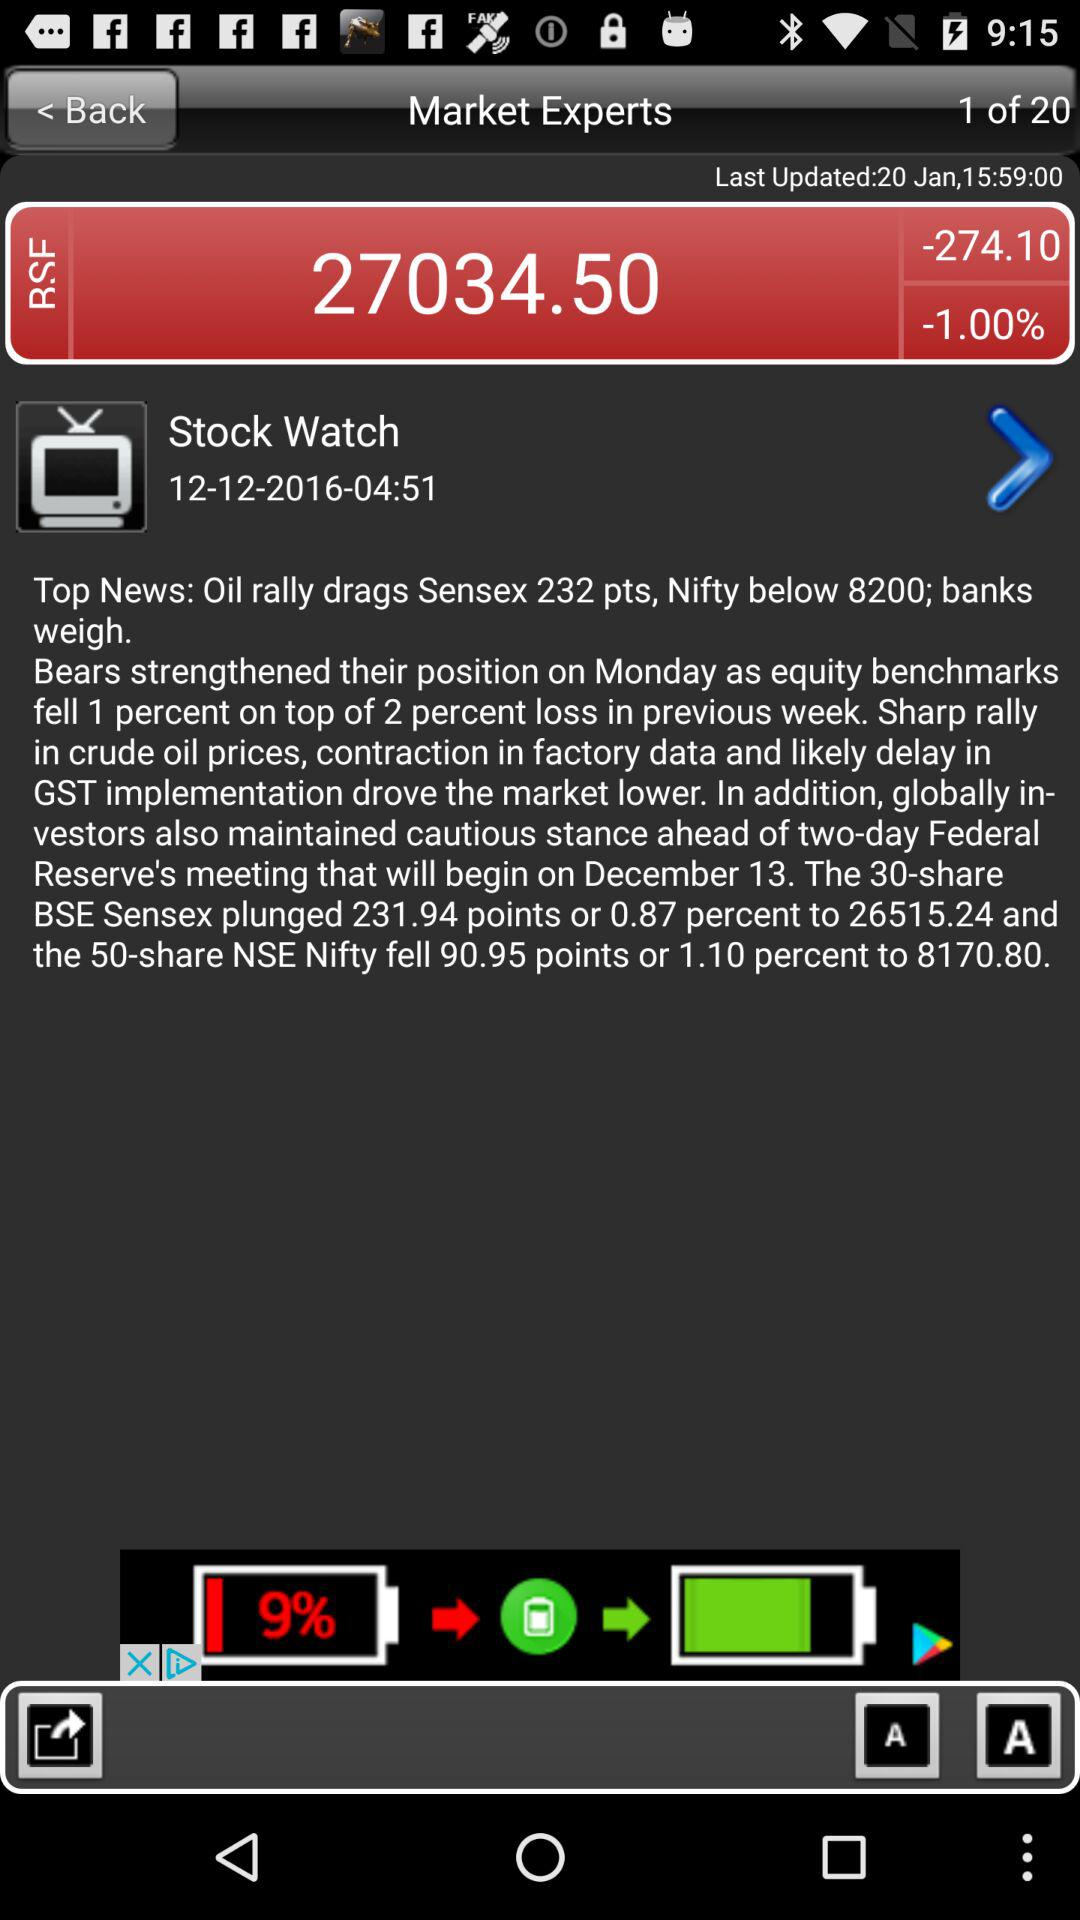What is the mentioned date of the stock watch? The mentioned date is December 12, 2016. 